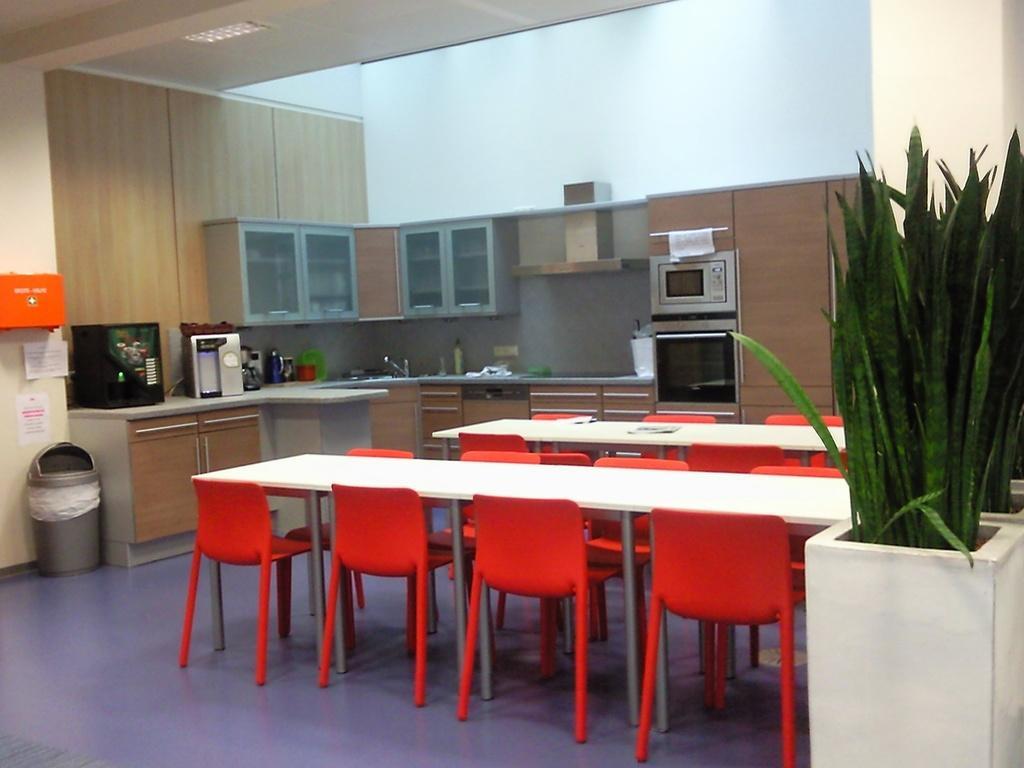In one or two sentences, can you explain what this image depicts? In this picture we can see tables, chairs plants, cupboards, plants, in, microwave oven, tap and some objects. 